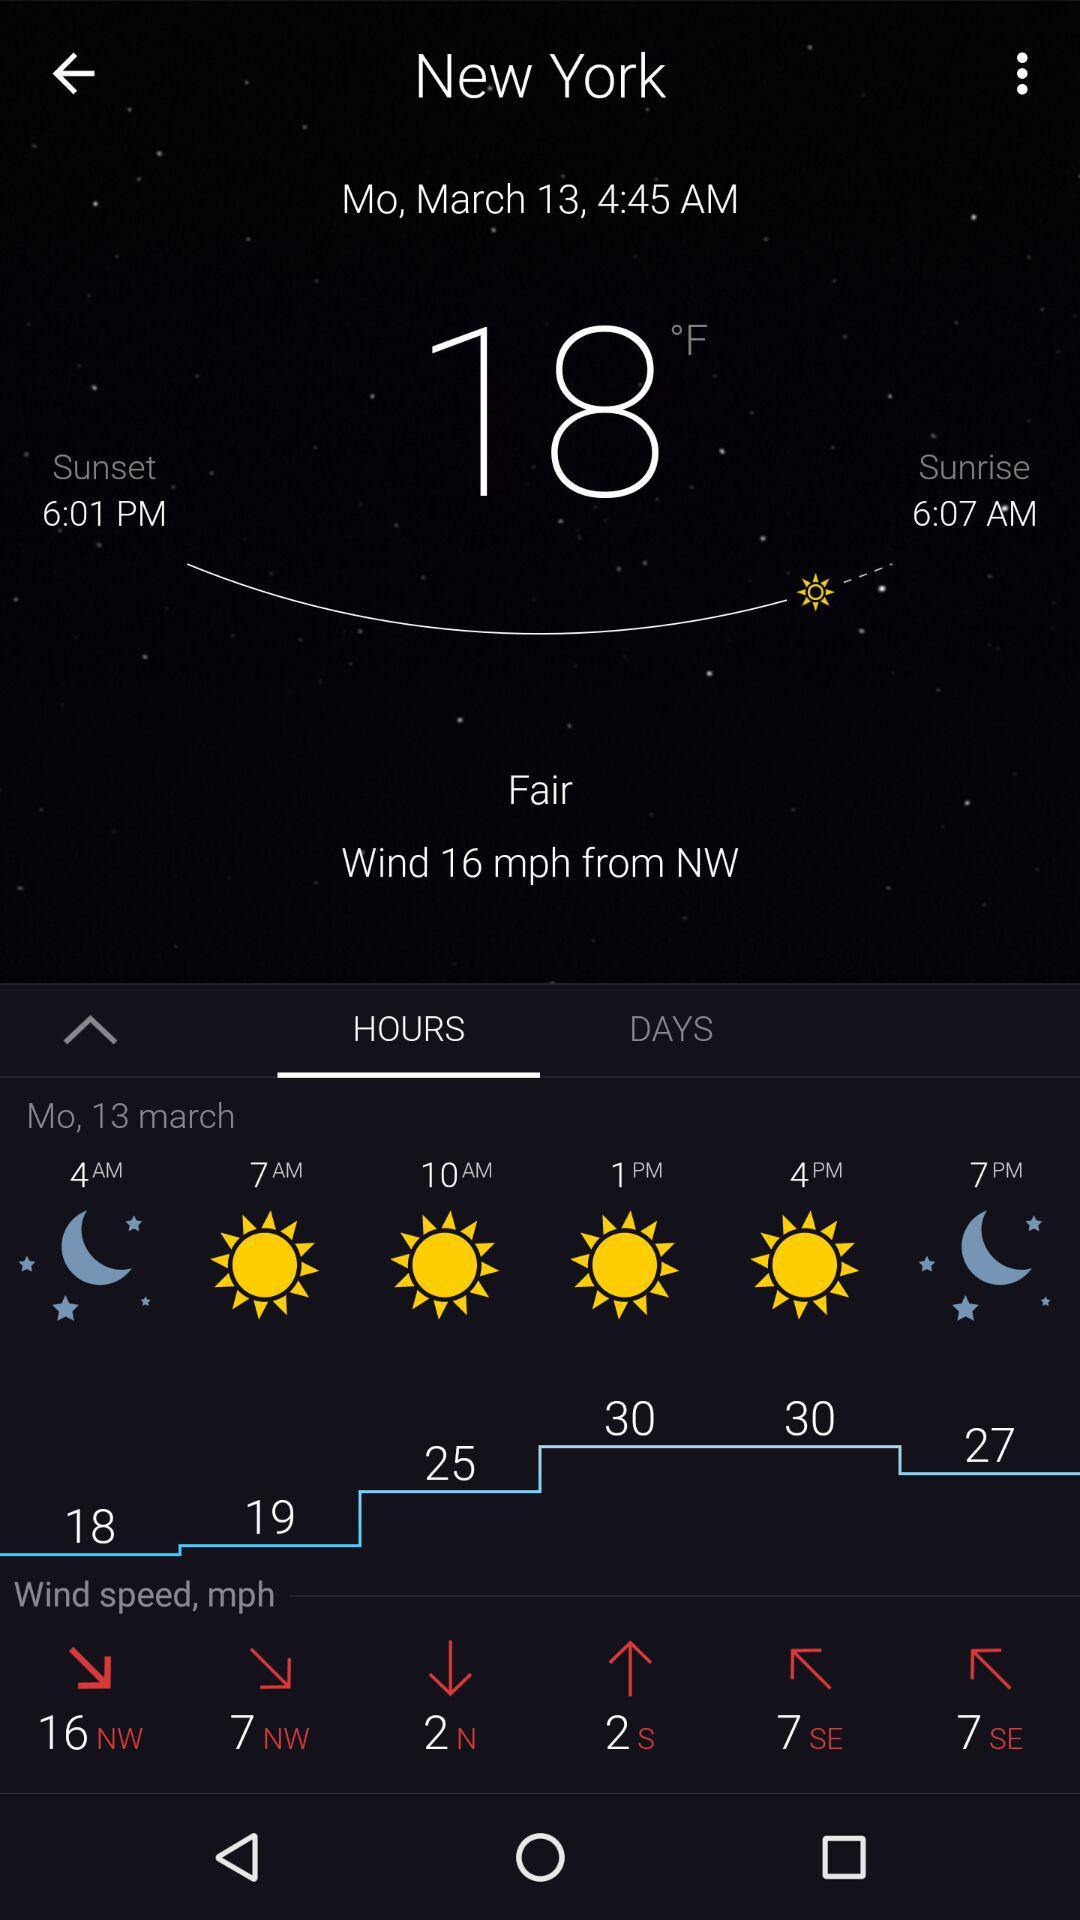What is the wind speed in miles per hour?
Answer the question using a single word or phrase. 16 mph 